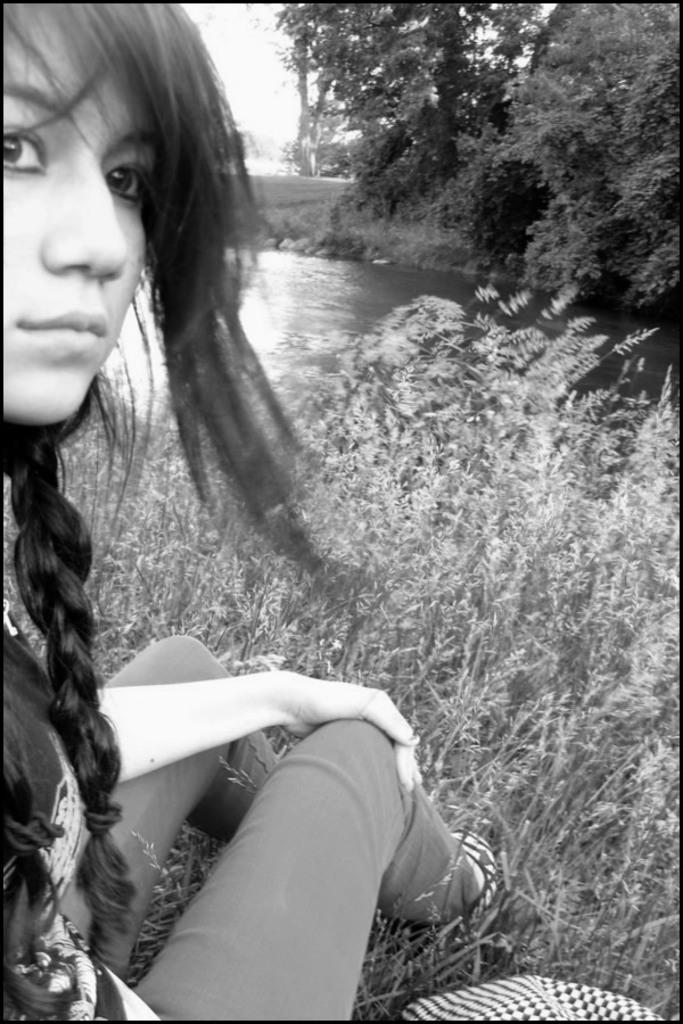What is the main subject of the image? There is a woman sitting in the image. What can be seen in the background of the image? The background of the image includes grass, water, trees, and the sky. What is the color scheme of the image? The image is black and white in color. What type of bait is the girl using while skateboarding in the image? There is no girl or skateboarding activity present in the image. 